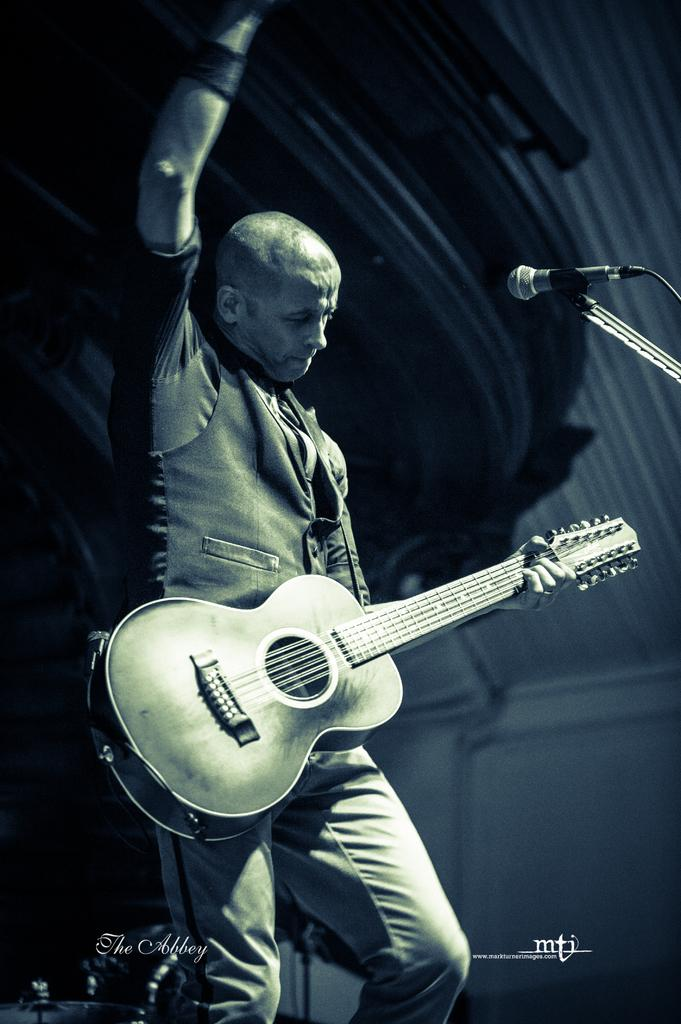What is the main subject of the image? There is a person in the image. What is the person doing in the image? The person is standing and holding a guitar. What object is present on the right side of the image? There is a microphone on the right side of the image. How many kittens are playing with the guitar in the image? There are no kittens present in the image, and therefore no such activity can be observed. 